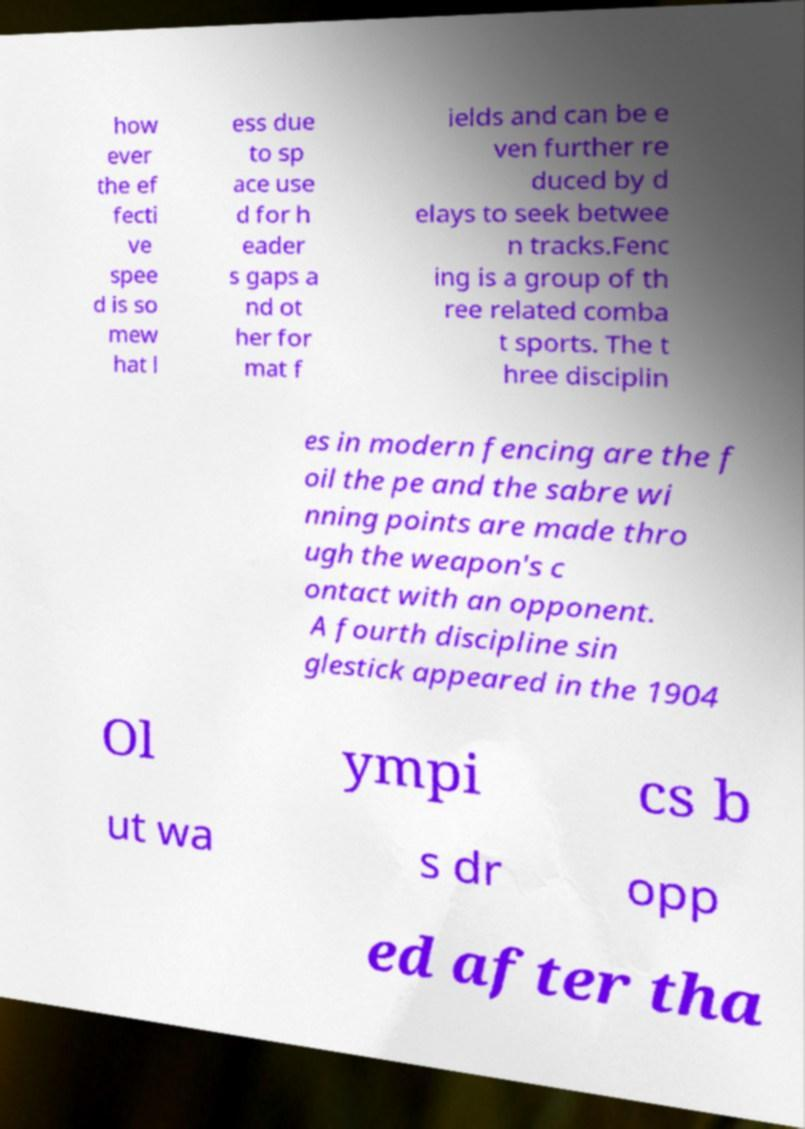Could you extract and type out the text from this image? how ever the ef fecti ve spee d is so mew hat l ess due to sp ace use d for h eader s gaps a nd ot her for mat f ields and can be e ven further re duced by d elays to seek betwee n tracks.Fenc ing is a group of th ree related comba t sports. The t hree disciplin es in modern fencing are the f oil the pe and the sabre wi nning points are made thro ugh the weapon's c ontact with an opponent. A fourth discipline sin glestick appeared in the 1904 Ol ympi cs b ut wa s dr opp ed after tha 